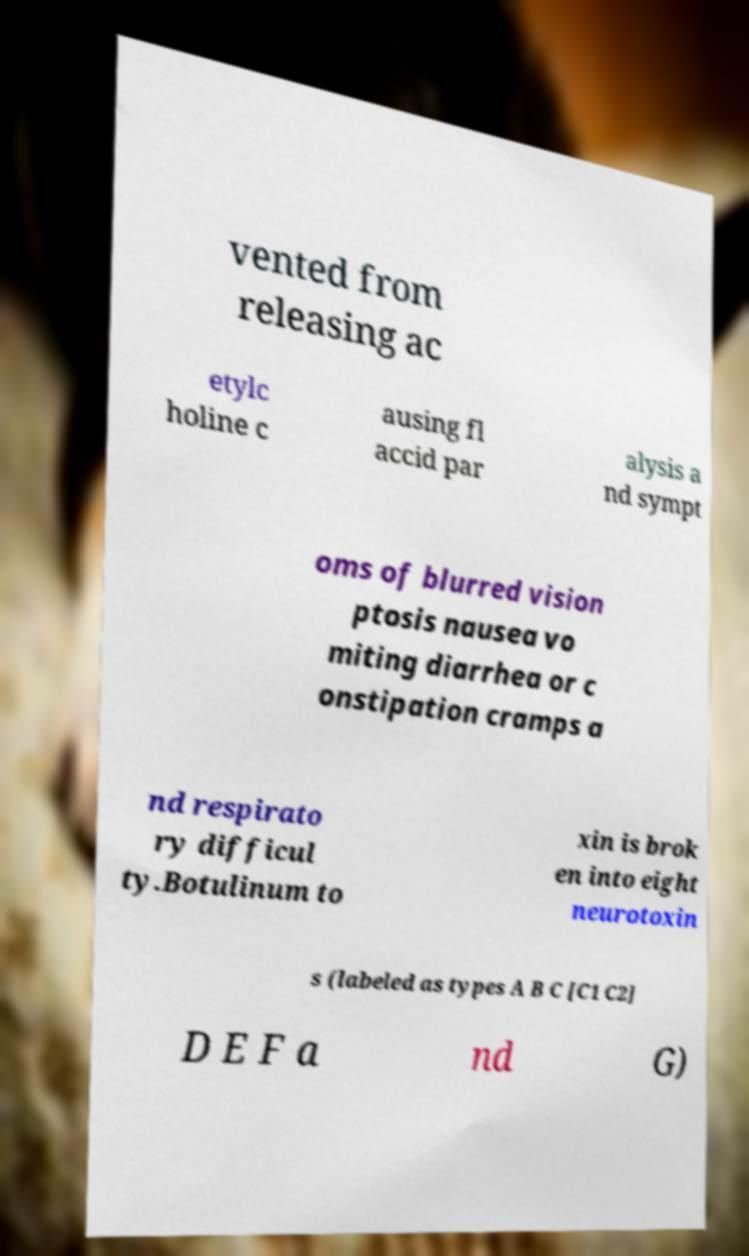Could you assist in decoding the text presented in this image and type it out clearly? vented from releasing ac etylc holine c ausing fl accid par alysis a nd sympt oms of blurred vision ptosis nausea vo miting diarrhea or c onstipation cramps a nd respirato ry difficul ty.Botulinum to xin is brok en into eight neurotoxin s (labeled as types A B C [C1 C2] D E F a nd G) 